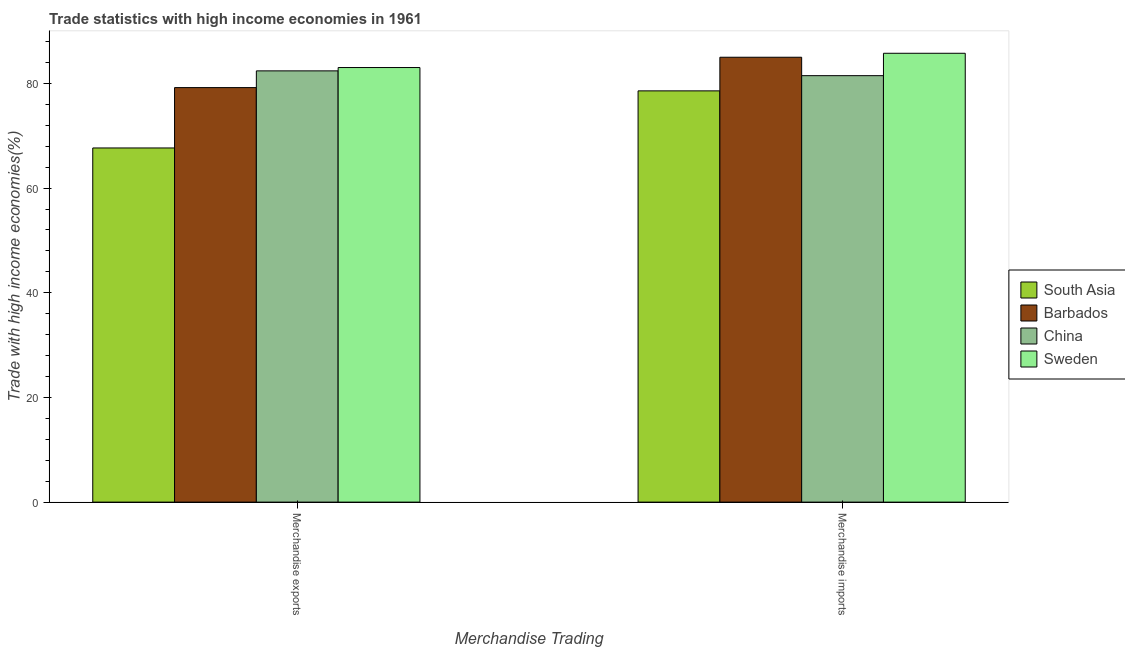How many different coloured bars are there?
Your answer should be very brief. 4. Are the number of bars on each tick of the X-axis equal?
Your answer should be very brief. Yes. How many bars are there on the 1st tick from the left?
Keep it short and to the point. 4. How many bars are there on the 2nd tick from the right?
Ensure brevity in your answer.  4. What is the label of the 1st group of bars from the left?
Make the answer very short. Merchandise exports. What is the merchandise exports in China?
Make the answer very short. 82.4. Across all countries, what is the maximum merchandise imports?
Make the answer very short. 85.76. Across all countries, what is the minimum merchandise imports?
Make the answer very short. 78.58. What is the total merchandise exports in the graph?
Offer a very short reply. 312.3. What is the difference between the merchandise exports in China and that in South Asia?
Your response must be concise. 14.73. What is the difference between the merchandise imports in South Asia and the merchandise exports in Sweden?
Give a very brief answer. -4.46. What is the average merchandise exports per country?
Keep it short and to the point. 78.07. What is the difference between the merchandise exports and merchandise imports in China?
Ensure brevity in your answer.  0.91. In how many countries, is the merchandise imports greater than 8 %?
Offer a very short reply. 4. What is the ratio of the merchandise imports in South Asia to that in China?
Offer a very short reply. 0.96. Is the merchandise exports in South Asia less than that in Barbados?
Provide a succinct answer. Yes. In how many countries, is the merchandise imports greater than the average merchandise imports taken over all countries?
Give a very brief answer. 2. What does the 2nd bar from the left in Merchandise exports represents?
Your answer should be compact. Barbados. Are all the bars in the graph horizontal?
Your answer should be compact. No. How many countries are there in the graph?
Your answer should be very brief. 4. Are the values on the major ticks of Y-axis written in scientific E-notation?
Provide a short and direct response. No. How many legend labels are there?
Your answer should be very brief. 4. How are the legend labels stacked?
Offer a very short reply. Vertical. What is the title of the graph?
Ensure brevity in your answer.  Trade statistics with high income economies in 1961. What is the label or title of the X-axis?
Ensure brevity in your answer.  Merchandise Trading. What is the label or title of the Y-axis?
Keep it short and to the point. Trade with high income economies(%). What is the Trade with high income economies(%) of South Asia in Merchandise exports?
Your response must be concise. 67.67. What is the Trade with high income economies(%) of Barbados in Merchandise exports?
Make the answer very short. 79.2. What is the Trade with high income economies(%) in China in Merchandise exports?
Your answer should be very brief. 82.4. What is the Trade with high income economies(%) in Sweden in Merchandise exports?
Offer a terse response. 83.03. What is the Trade with high income economies(%) of South Asia in Merchandise imports?
Your answer should be compact. 78.58. What is the Trade with high income economies(%) of China in Merchandise imports?
Offer a very short reply. 81.48. What is the Trade with high income economies(%) in Sweden in Merchandise imports?
Keep it short and to the point. 85.76. Across all Merchandise Trading, what is the maximum Trade with high income economies(%) in South Asia?
Make the answer very short. 78.58. Across all Merchandise Trading, what is the maximum Trade with high income economies(%) of Barbados?
Your answer should be very brief. 85. Across all Merchandise Trading, what is the maximum Trade with high income economies(%) of China?
Provide a succinct answer. 82.4. Across all Merchandise Trading, what is the maximum Trade with high income economies(%) of Sweden?
Your answer should be compact. 85.76. Across all Merchandise Trading, what is the minimum Trade with high income economies(%) in South Asia?
Your response must be concise. 67.67. Across all Merchandise Trading, what is the minimum Trade with high income economies(%) of Barbados?
Your answer should be compact. 79.2. Across all Merchandise Trading, what is the minimum Trade with high income economies(%) of China?
Keep it short and to the point. 81.48. Across all Merchandise Trading, what is the minimum Trade with high income economies(%) of Sweden?
Keep it short and to the point. 83.03. What is the total Trade with high income economies(%) of South Asia in the graph?
Your response must be concise. 146.25. What is the total Trade with high income economies(%) in Barbados in the graph?
Your answer should be compact. 164.2. What is the total Trade with high income economies(%) in China in the graph?
Give a very brief answer. 163.88. What is the total Trade with high income economies(%) in Sweden in the graph?
Your answer should be very brief. 168.79. What is the difference between the Trade with high income economies(%) in South Asia in Merchandise exports and that in Merchandise imports?
Provide a short and direct response. -10.91. What is the difference between the Trade with high income economies(%) of China in Merchandise exports and that in Merchandise imports?
Provide a short and direct response. 0.91. What is the difference between the Trade with high income economies(%) in Sweden in Merchandise exports and that in Merchandise imports?
Your answer should be compact. -2.73. What is the difference between the Trade with high income economies(%) of South Asia in Merchandise exports and the Trade with high income economies(%) of Barbados in Merchandise imports?
Keep it short and to the point. -17.33. What is the difference between the Trade with high income economies(%) in South Asia in Merchandise exports and the Trade with high income economies(%) in China in Merchandise imports?
Make the answer very short. -13.81. What is the difference between the Trade with high income economies(%) in South Asia in Merchandise exports and the Trade with high income economies(%) in Sweden in Merchandise imports?
Keep it short and to the point. -18.09. What is the difference between the Trade with high income economies(%) in Barbados in Merchandise exports and the Trade with high income economies(%) in China in Merchandise imports?
Provide a succinct answer. -2.28. What is the difference between the Trade with high income economies(%) of Barbados in Merchandise exports and the Trade with high income economies(%) of Sweden in Merchandise imports?
Offer a terse response. -6.56. What is the difference between the Trade with high income economies(%) of China in Merchandise exports and the Trade with high income economies(%) of Sweden in Merchandise imports?
Offer a terse response. -3.36. What is the average Trade with high income economies(%) in South Asia per Merchandise Trading?
Ensure brevity in your answer.  73.12. What is the average Trade with high income economies(%) in Barbados per Merchandise Trading?
Ensure brevity in your answer.  82.1. What is the average Trade with high income economies(%) of China per Merchandise Trading?
Keep it short and to the point. 81.94. What is the average Trade with high income economies(%) in Sweden per Merchandise Trading?
Offer a terse response. 84.4. What is the difference between the Trade with high income economies(%) in South Asia and Trade with high income economies(%) in Barbados in Merchandise exports?
Your response must be concise. -11.53. What is the difference between the Trade with high income economies(%) in South Asia and Trade with high income economies(%) in China in Merchandise exports?
Ensure brevity in your answer.  -14.73. What is the difference between the Trade with high income economies(%) in South Asia and Trade with high income economies(%) in Sweden in Merchandise exports?
Ensure brevity in your answer.  -15.37. What is the difference between the Trade with high income economies(%) of Barbados and Trade with high income economies(%) of China in Merchandise exports?
Offer a very short reply. -3.2. What is the difference between the Trade with high income economies(%) in Barbados and Trade with high income economies(%) in Sweden in Merchandise exports?
Provide a short and direct response. -3.83. What is the difference between the Trade with high income economies(%) of China and Trade with high income economies(%) of Sweden in Merchandise exports?
Offer a terse response. -0.64. What is the difference between the Trade with high income economies(%) in South Asia and Trade with high income economies(%) in Barbados in Merchandise imports?
Your response must be concise. -6.42. What is the difference between the Trade with high income economies(%) in South Asia and Trade with high income economies(%) in China in Merchandise imports?
Your response must be concise. -2.9. What is the difference between the Trade with high income economies(%) of South Asia and Trade with high income economies(%) of Sweden in Merchandise imports?
Your response must be concise. -7.18. What is the difference between the Trade with high income economies(%) in Barbados and Trade with high income economies(%) in China in Merchandise imports?
Offer a very short reply. 3.52. What is the difference between the Trade with high income economies(%) of Barbados and Trade with high income economies(%) of Sweden in Merchandise imports?
Offer a very short reply. -0.76. What is the difference between the Trade with high income economies(%) of China and Trade with high income economies(%) of Sweden in Merchandise imports?
Provide a succinct answer. -4.28. What is the ratio of the Trade with high income economies(%) in South Asia in Merchandise exports to that in Merchandise imports?
Your answer should be very brief. 0.86. What is the ratio of the Trade with high income economies(%) in Barbados in Merchandise exports to that in Merchandise imports?
Offer a very short reply. 0.93. What is the ratio of the Trade with high income economies(%) of China in Merchandise exports to that in Merchandise imports?
Provide a short and direct response. 1.01. What is the ratio of the Trade with high income economies(%) in Sweden in Merchandise exports to that in Merchandise imports?
Your answer should be compact. 0.97. What is the difference between the highest and the second highest Trade with high income economies(%) of South Asia?
Offer a very short reply. 10.91. What is the difference between the highest and the second highest Trade with high income economies(%) of Barbados?
Offer a terse response. 5.8. What is the difference between the highest and the second highest Trade with high income economies(%) in China?
Ensure brevity in your answer.  0.91. What is the difference between the highest and the second highest Trade with high income economies(%) of Sweden?
Offer a very short reply. 2.73. What is the difference between the highest and the lowest Trade with high income economies(%) of South Asia?
Offer a very short reply. 10.91. What is the difference between the highest and the lowest Trade with high income economies(%) of China?
Offer a terse response. 0.91. What is the difference between the highest and the lowest Trade with high income economies(%) in Sweden?
Offer a very short reply. 2.73. 